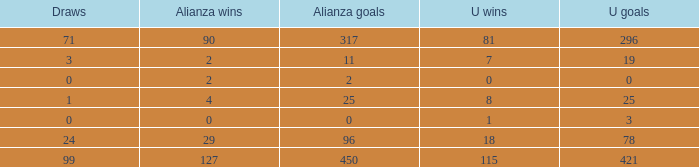What is the sum of Alianza Wins, when Alianza Goals is "317, and when U Goals is greater than 296? None. 